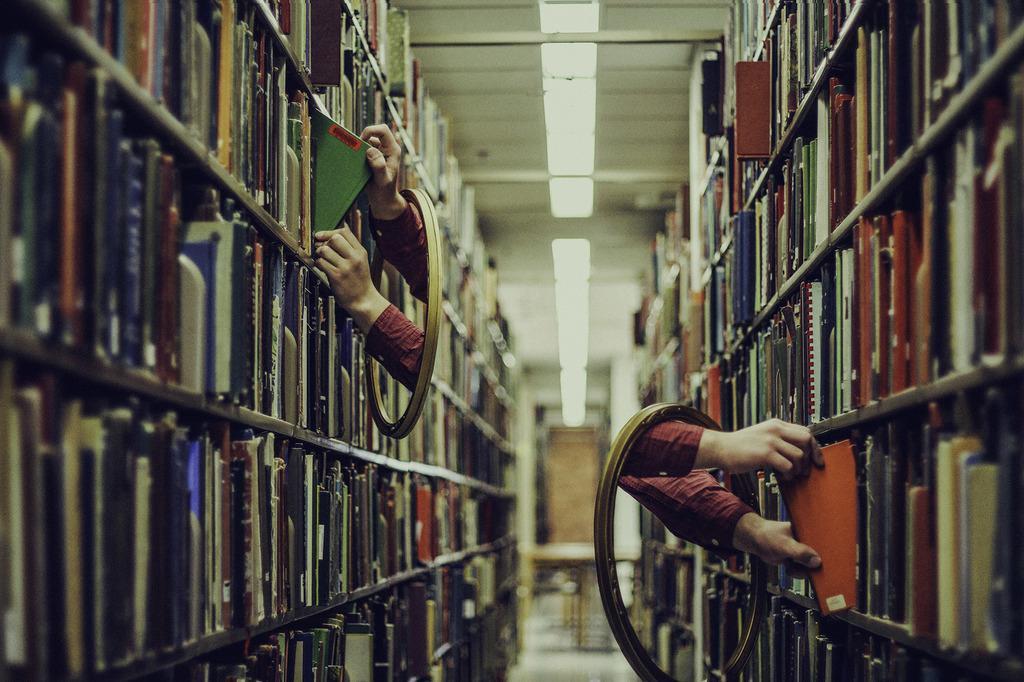Can you describe this image briefly? In this image I can see few books in the shelves. I can see a person's hands. 